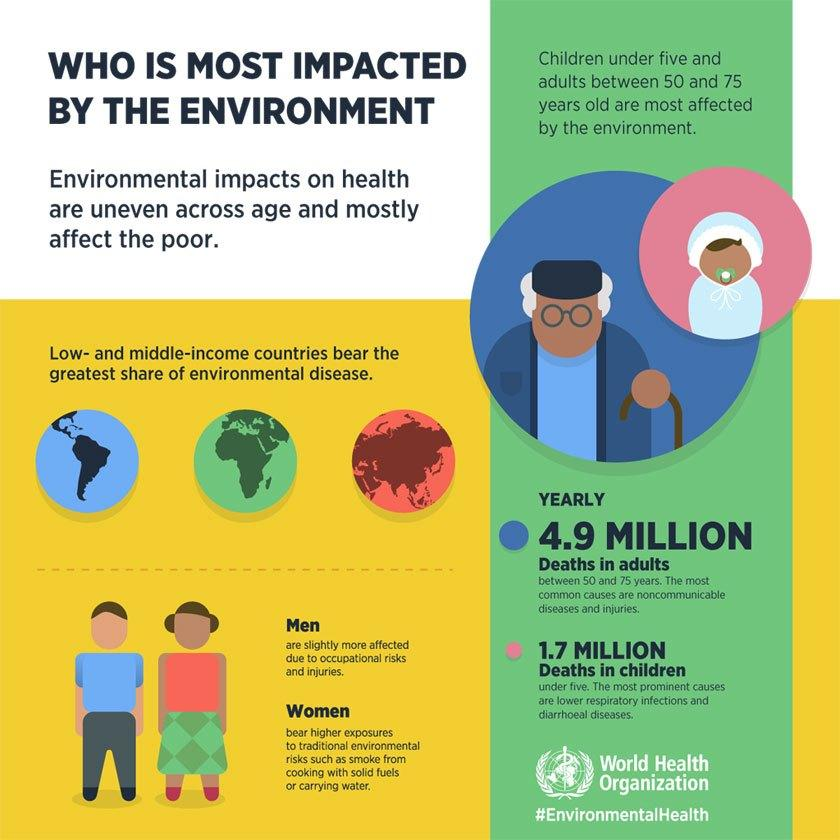Point out several critical features in this image. Men are more susceptible to environmental diseases than women. The age group most likely to be affected by environmental diseases is individuals between 50 and 60 years old, according to studies. Low-income countries are more likely to be affected by environmental diseases than high-income countries. 